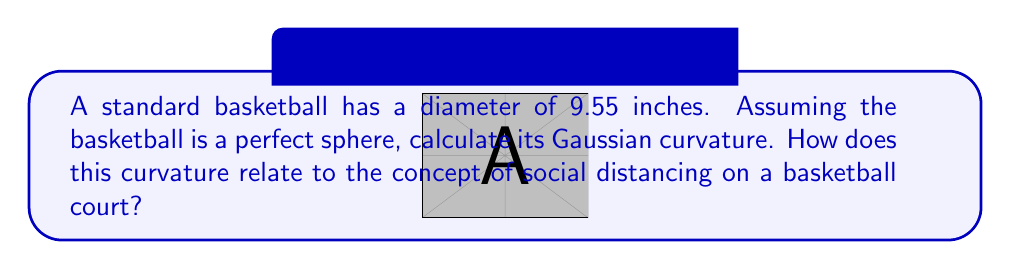Help me with this question. Let's approach this step-by-step:

1) The Gaussian curvature ($K$) of a sphere is constant and given by the formula:

   $$K = \frac{1}{R^2}$$

   where $R$ is the radius of the sphere.

2) We're given the diameter of the basketball, so let's first calculate the radius:

   $$R = \frac{9.55}{2} = 4.775 \text{ inches}$$

3) Now we can substitute this into our formula:

   $$K = \frac{1}{(4.775)^2} = 0.0439 \text{ in}^{-2}$$

4) To relate this to social distancing on a basketball court:

   The Gaussian curvature of 0.0439 in^(-2) means that the basketball's surface curves significantly in a small area. In contrast, a basketball court is essentially flat (Gaussian curvature ≈ 0).

   This difference in curvature can be used as an analogy for social distancing:
   - On the highly curved basketball surface, points that seem close can actually be far apart when you follow the surface.
   - Similarly, players on a court might seem close from one perspective, but maintaining proper spacing (like points on a curved surface) can keep them at safe distances.

5) The coach could use this concept to visualize spacing strategies, emphasizing how proper positioning can maintain safe distances even in a confined space like a basketball court.
Answer: $K = 0.0439 \text{ in}^{-2}$ 